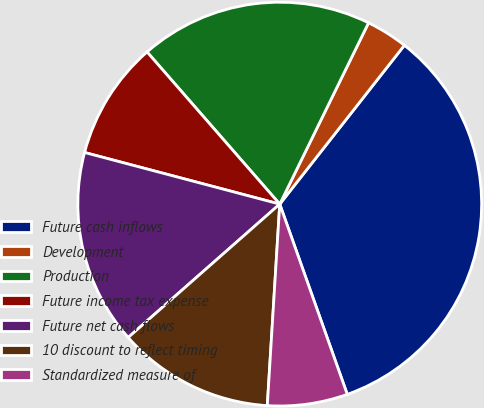Convert chart to OTSL. <chart><loc_0><loc_0><loc_500><loc_500><pie_chart><fcel>Future cash inflows<fcel>Development<fcel>Production<fcel>Future income tax expense<fcel>Future net cash flows<fcel>10 discount to reflect timing<fcel>Standardized measure of<nl><fcel>33.98%<fcel>3.34%<fcel>18.66%<fcel>9.47%<fcel>15.6%<fcel>12.53%<fcel>6.41%<nl></chart> 